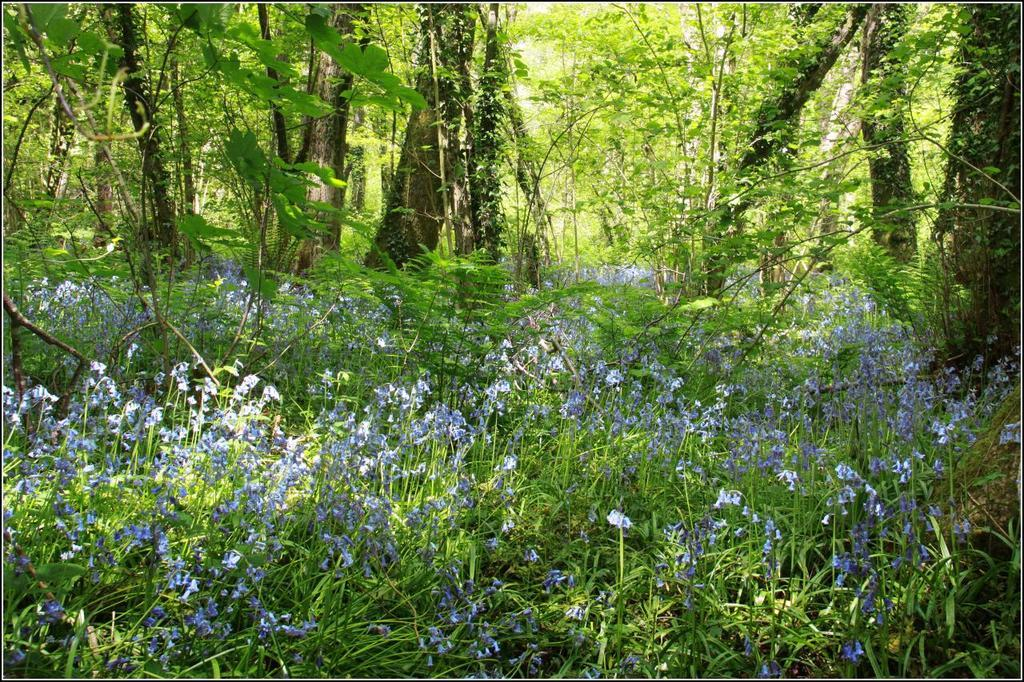What types of vegetation are present in the image? The image contains trees and plants. Can you describe the flowers in the image? Yes, there are flowers in the middle of the image. Who is the creator of the party depicted in the image? There is no party depicted in the image; it features trees, plants, and flowers. How many beans are visible in the image? There are no beans present in the image. 